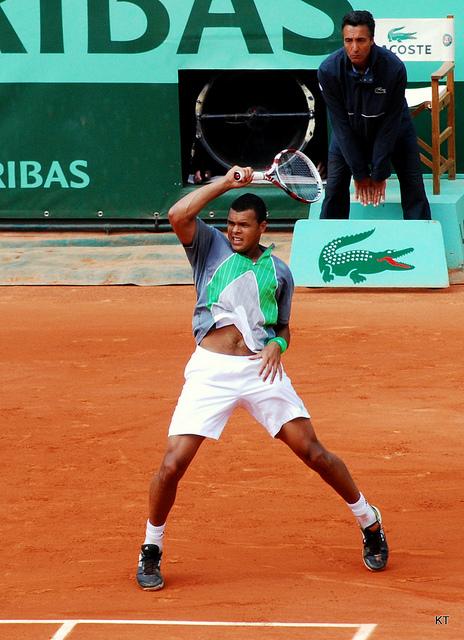What color is the player's shorts?
Answer briefly. White. What sport is he playing?
Answer briefly. Tennis. How many people are seen?
Concise answer only. 2. What color shorts is the man wearing?
Short answer required. White. Is he about to hit the ball?
Keep it brief. Yes. What is the animal in the background?
Short answer required. Alligator. 